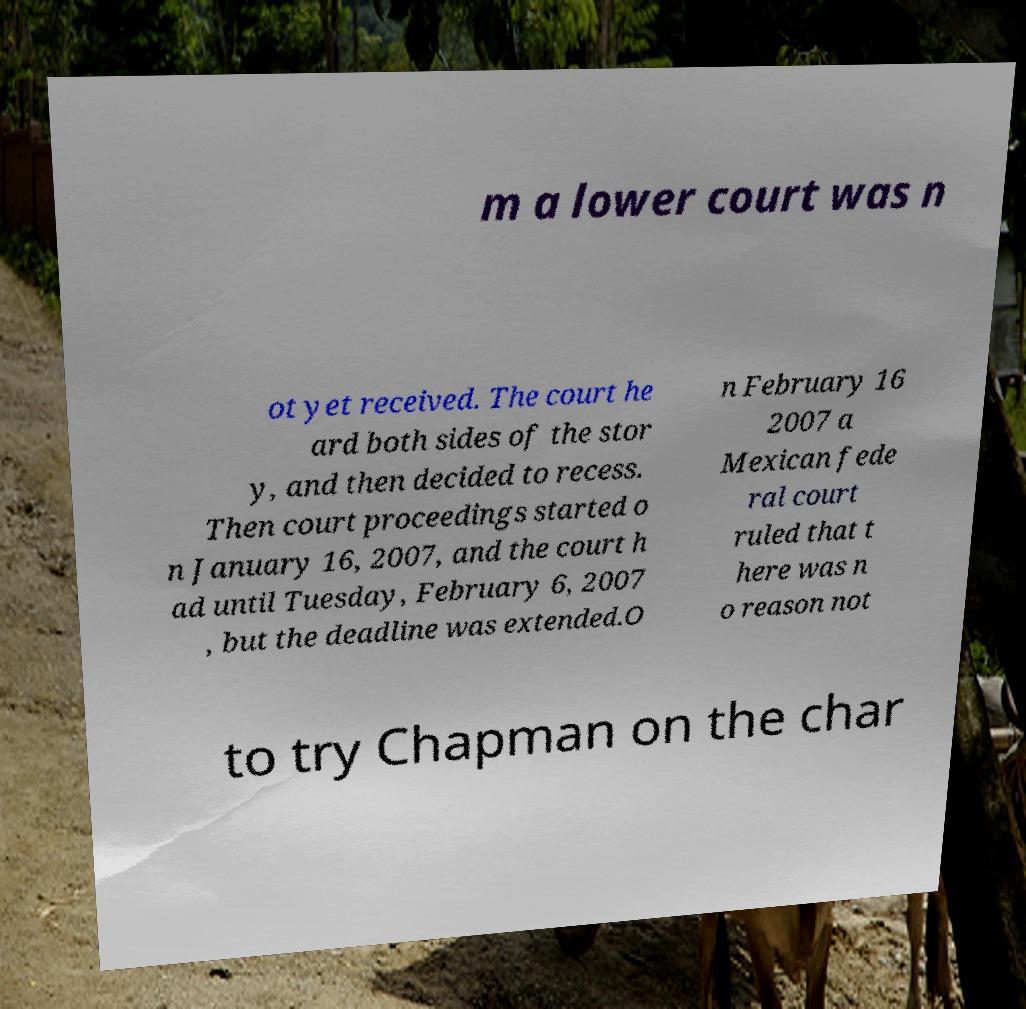Could you extract and type out the text from this image? m a lower court was n ot yet received. The court he ard both sides of the stor y, and then decided to recess. Then court proceedings started o n January 16, 2007, and the court h ad until Tuesday, February 6, 2007 , but the deadline was extended.O n February 16 2007 a Mexican fede ral court ruled that t here was n o reason not to try Chapman on the char 